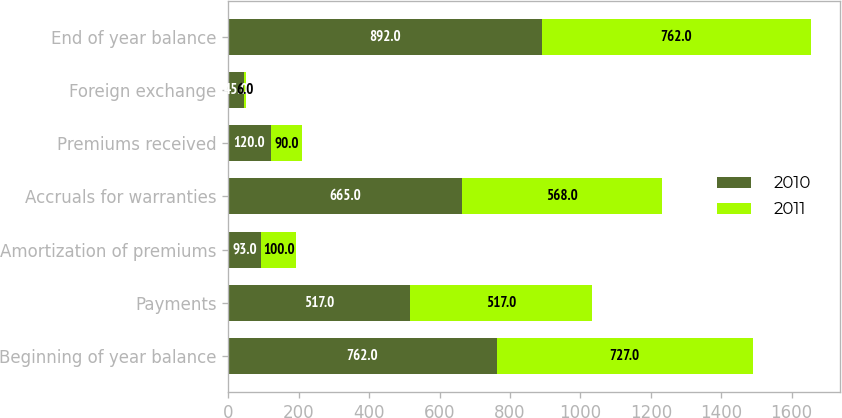Convert chart to OTSL. <chart><loc_0><loc_0><loc_500><loc_500><stacked_bar_chart><ecel><fcel>Beginning of year balance<fcel>Payments<fcel>Amortization of premiums<fcel>Accruals for warranties<fcel>Premiums received<fcel>Foreign exchange<fcel>End of year balance<nl><fcel>2010<fcel>762<fcel>517<fcel>93<fcel>665<fcel>120<fcel>45<fcel>892<nl><fcel>2011<fcel>727<fcel>517<fcel>100<fcel>568<fcel>90<fcel>6<fcel>762<nl></chart> 